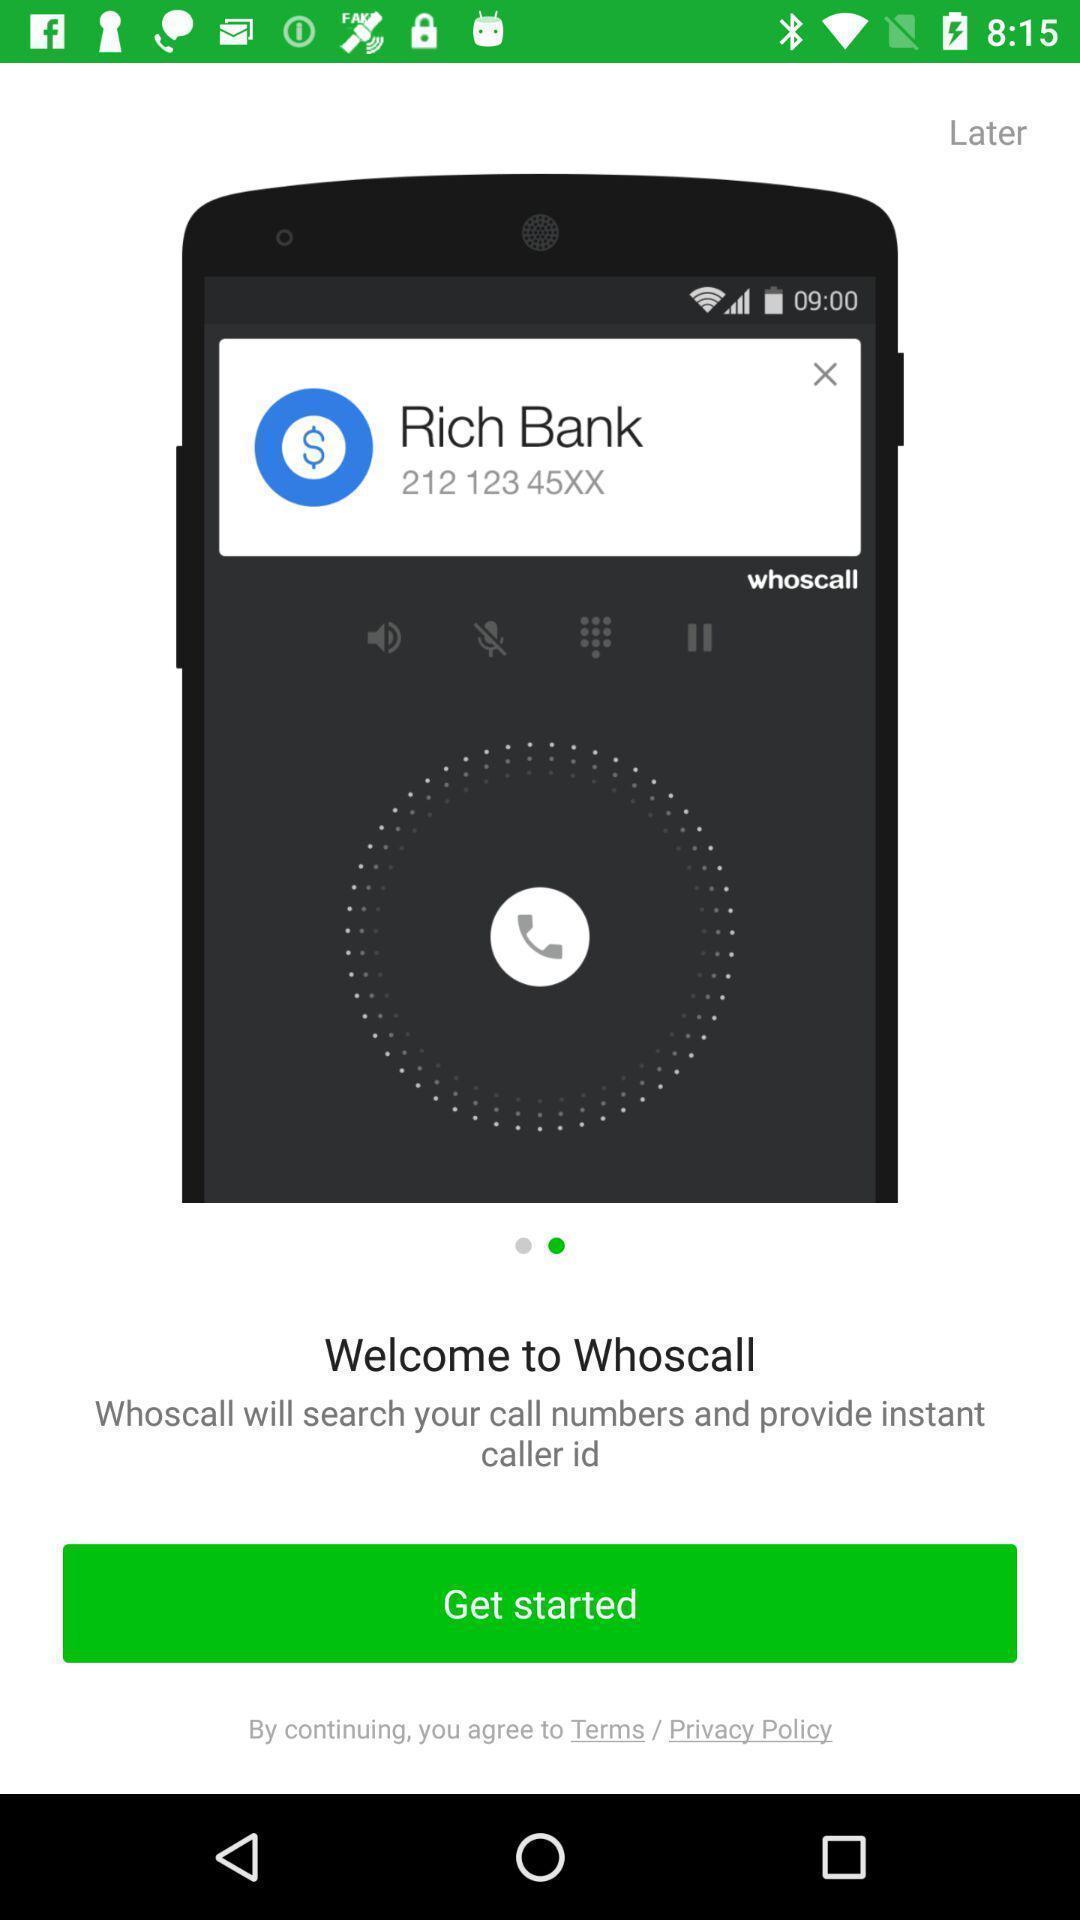Explain the elements present in this screenshot. Welcome page of mobile caller app. 